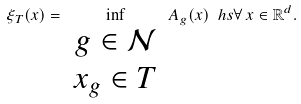<formula> <loc_0><loc_0><loc_500><loc_500>\xi _ { T } ( x ) = \inf _ { \begin{array} { c } g \in \mathcal { N } \\ x _ { g } \in T \end{array} } A _ { g } ( x ) \ h s \forall \, x \in \mathbb { R } ^ { d } .</formula> 